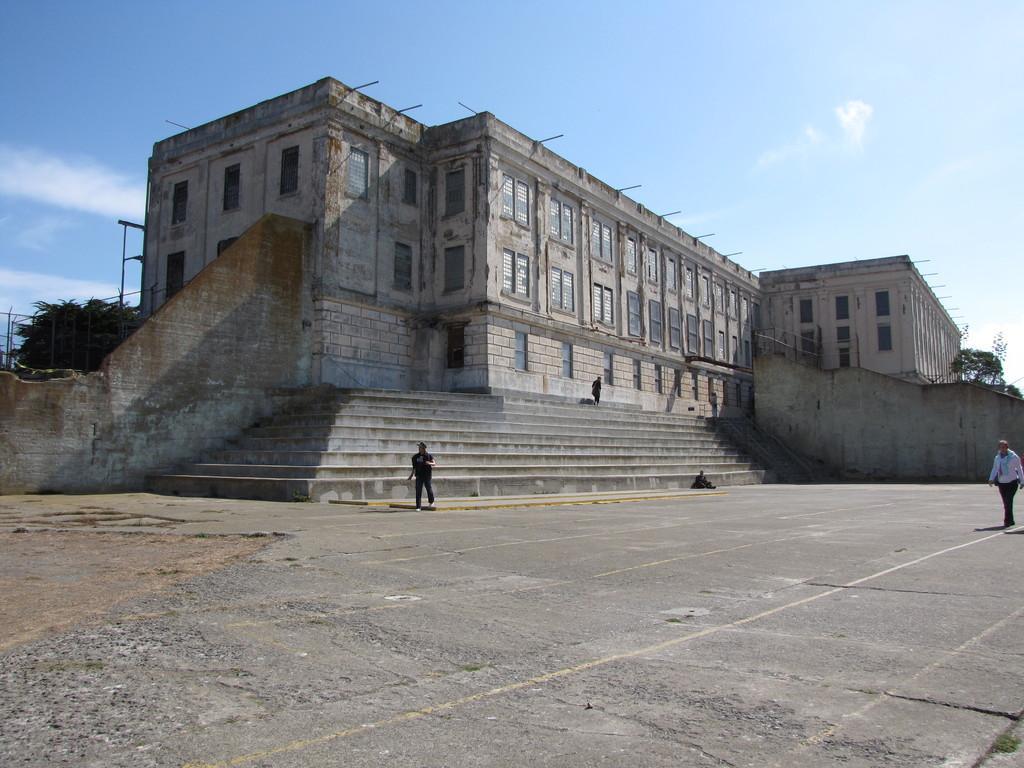In one or two sentences, can you explain what this image depicts? This image consists of a building along with windows. In the front, there are steps. At the bottom, there is a road. There are four people in this image. To the left, there is a tree. At the top, there is sky. 